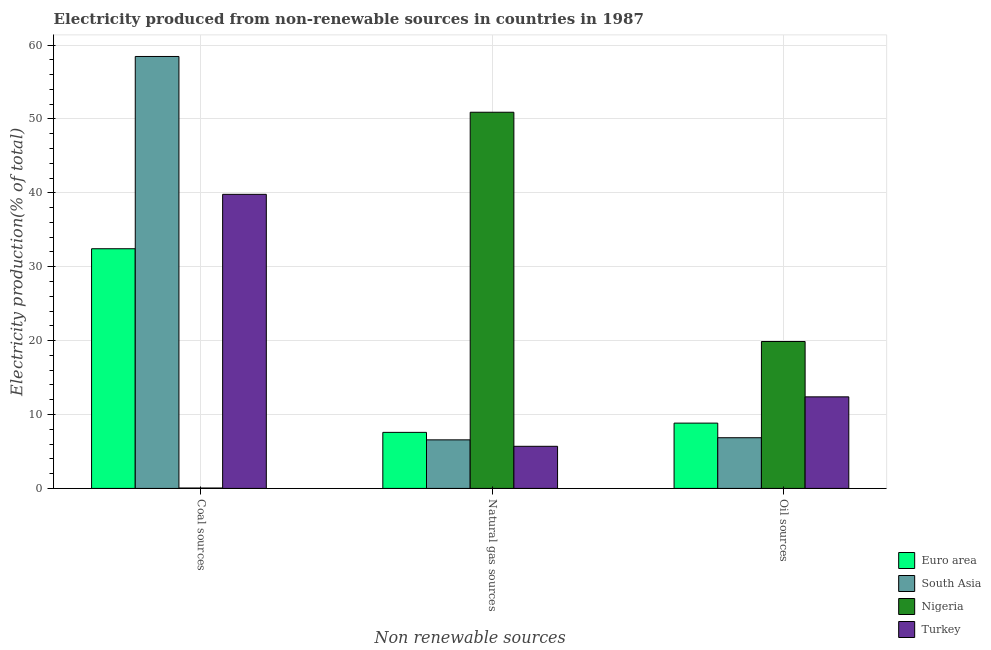How many groups of bars are there?
Provide a short and direct response. 3. Are the number of bars per tick equal to the number of legend labels?
Make the answer very short. Yes. Are the number of bars on each tick of the X-axis equal?
Provide a succinct answer. Yes. How many bars are there on the 3rd tick from the left?
Your answer should be compact. 4. What is the label of the 1st group of bars from the left?
Offer a very short reply. Coal sources. What is the percentage of electricity produced by natural gas in Nigeria?
Your answer should be very brief. 50.91. Across all countries, what is the maximum percentage of electricity produced by coal?
Provide a succinct answer. 58.46. Across all countries, what is the minimum percentage of electricity produced by coal?
Offer a terse response. 0.05. In which country was the percentage of electricity produced by oil sources maximum?
Your answer should be compact. Nigeria. What is the total percentage of electricity produced by coal in the graph?
Provide a succinct answer. 130.75. What is the difference between the percentage of electricity produced by natural gas in Nigeria and that in Turkey?
Ensure brevity in your answer.  45.21. What is the difference between the percentage of electricity produced by natural gas in Euro area and the percentage of electricity produced by oil sources in South Asia?
Offer a terse response. 0.73. What is the average percentage of electricity produced by natural gas per country?
Provide a succinct answer. 17.69. What is the difference between the percentage of electricity produced by natural gas and percentage of electricity produced by coal in Nigeria?
Offer a terse response. 50.86. In how many countries, is the percentage of electricity produced by coal greater than 24 %?
Ensure brevity in your answer.  3. What is the ratio of the percentage of electricity produced by natural gas in South Asia to that in Nigeria?
Make the answer very short. 0.13. Is the percentage of electricity produced by natural gas in Euro area less than that in South Asia?
Provide a succinct answer. No. What is the difference between the highest and the second highest percentage of electricity produced by coal?
Provide a short and direct response. 18.66. What is the difference between the highest and the lowest percentage of electricity produced by natural gas?
Make the answer very short. 45.21. Is the sum of the percentage of electricity produced by natural gas in Nigeria and South Asia greater than the maximum percentage of electricity produced by coal across all countries?
Make the answer very short. No. What does the 2nd bar from the right in Coal sources represents?
Provide a short and direct response. Nigeria. Is it the case that in every country, the sum of the percentage of electricity produced by coal and percentage of electricity produced by natural gas is greater than the percentage of electricity produced by oil sources?
Your answer should be very brief. Yes. How many bars are there?
Keep it short and to the point. 12. How many countries are there in the graph?
Offer a terse response. 4. What is the difference between two consecutive major ticks on the Y-axis?
Your response must be concise. 10. Where does the legend appear in the graph?
Give a very brief answer. Bottom right. How are the legend labels stacked?
Your response must be concise. Vertical. What is the title of the graph?
Make the answer very short. Electricity produced from non-renewable sources in countries in 1987. What is the label or title of the X-axis?
Offer a very short reply. Non renewable sources. What is the label or title of the Y-axis?
Provide a short and direct response. Electricity production(% of total). What is the Electricity production(% of total) in Euro area in Coal sources?
Your response must be concise. 32.44. What is the Electricity production(% of total) of South Asia in Coal sources?
Your answer should be very brief. 58.46. What is the Electricity production(% of total) in Nigeria in Coal sources?
Provide a succinct answer. 0.05. What is the Electricity production(% of total) of Turkey in Coal sources?
Offer a very short reply. 39.8. What is the Electricity production(% of total) of Euro area in Natural gas sources?
Your response must be concise. 7.58. What is the Electricity production(% of total) of South Asia in Natural gas sources?
Provide a succinct answer. 6.57. What is the Electricity production(% of total) of Nigeria in Natural gas sources?
Give a very brief answer. 50.91. What is the Electricity production(% of total) of Turkey in Natural gas sources?
Your answer should be compact. 5.7. What is the Electricity production(% of total) of Euro area in Oil sources?
Provide a succinct answer. 8.84. What is the Electricity production(% of total) of South Asia in Oil sources?
Your answer should be compact. 6.86. What is the Electricity production(% of total) of Nigeria in Oil sources?
Keep it short and to the point. 19.88. What is the Electricity production(% of total) in Turkey in Oil sources?
Provide a succinct answer. 12.39. Across all Non renewable sources, what is the maximum Electricity production(% of total) of Euro area?
Make the answer very short. 32.44. Across all Non renewable sources, what is the maximum Electricity production(% of total) in South Asia?
Keep it short and to the point. 58.46. Across all Non renewable sources, what is the maximum Electricity production(% of total) in Nigeria?
Your answer should be very brief. 50.91. Across all Non renewable sources, what is the maximum Electricity production(% of total) in Turkey?
Ensure brevity in your answer.  39.8. Across all Non renewable sources, what is the minimum Electricity production(% of total) of Euro area?
Keep it short and to the point. 7.58. Across all Non renewable sources, what is the minimum Electricity production(% of total) of South Asia?
Your answer should be very brief. 6.57. Across all Non renewable sources, what is the minimum Electricity production(% of total) in Nigeria?
Make the answer very short. 0.05. Across all Non renewable sources, what is the minimum Electricity production(% of total) of Turkey?
Give a very brief answer. 5.7. What is the total Electricity production(% of total) in Euro area in the graph?
Make the answer very short. 48.86. What is the total Electricity production(% of total) in South Asia in the graph?
Your answer should be compact. 71.89. What is the total Electricity production(% of total) of Nigeria in the graph?
Give a very brief answer. 70.85. What is the total Electricity production(% of total) of Turkey in the graph?
Provide a short and direct response. 57.89. What is the difference between the Electricity production(% of total) in Euro area in Coal sources and that in Natural gas sources?
Your response must be concise. 24.85. What is the difference between the Electricity production(% of total) in South Asia in Coal sources and that in Natural gas sources?
Give a very brief answer. 51.89. What is the difference between the Electricity production(% of total) of Nigeria in Coal sources and that in Natural gas sources?
Offer a very short reply. -50.86. What is the difference between the Electricity production(% of total) of Turkey in Coal sources and that in Natural gas sources?
Make the answer very short. 34.1. What is the difference between the Electricity production(% of total) in Euro area in Coal sources and that in Oil sources?
Give a very brief answer. 23.6. What is the difference between the Electricity production(% of total) in South Asia in Coal sources and that in Oil sources?
Give a very brief answer. 51.6. What is the difference between the Electricity production(% of total) of Nigeria in Coal sources and that in Oil sources?
Offer a very short reply. -19.83. What is the difference between the Electricity production(% of total) of Turkey in Coal sources and that in Oil sources?
Make the answer very short. 27.41. What is the difference between the Electricity production(% of total) of Euro area in Natural gas sources and that in Oil sources?
Provide a succinct answer. -1.25. What is the difference between the Electricity production(% of total) in South Asia in Natural gas sources and that in Oil sources?
Offer a terse response. -0.29. What is the difference between the Electricity production(% of total) in Nigeria in Natural gas sources and that in Oil sources?
Provide a short and direct response. 31.03. What is the difference between the Electricity production(% of total) in Turkey in Natural gas sources and that in Oil sources?
Give a very brief answer. -6.69. What is the difference between the Electricity production(% of total) of Euro area in Coal sources and the Electricity production(% of total) of South Asia in Natural gas sources?
Ensure brevity in your answer.  25.86. What is the difference between the Electricity production(% of total) in Euro area in Coal sources and the Electricity production(% of total) in Nigeria in Natural gas sources?
Make the answer very short. -18.47. What is the difference between the Electricity production(% of total) of Euro area in Coal sources and the Electricity production(% of total) of Turkey in Natural gas sources?
Provide a succinct answer. 26.74. What is the difference between the Electricity production(% of total) in South Asia in Coal sources and the Electricity production(% of total) in Nigeria in Natural gas sources?
Give a very brief answer. 7.55. What is the difference between the Electricity production(% of total) of South Asia in Coal sources and the Electricity production(% of total) of Turkey in Natural gas sources?
Provide a short and direct response. 52.76. What is the difference between the Electricity production(% of total) of Nigeria in Coal sources and the Electricity production(% of total) of Turkey in Natural gas sources?
Your response must be concise. -5.65. What is the difference between the Electricity production(% of total) of Euro area in Coal sources and the Electricity production(% of total) of South Asia in Oil sources?
Offer a terse response. 25.58. What is the difference between the Electricity production(% of total) in Euro area in Coal sources and the Electricity production(% of total) in Nigeria in Oil sources?
Your answer should be compact. 12.55. What is the difference between the Electricity production(% of total) in Euro area in Coal sources and the Electricity production(% of total) in Turkey in Oil sources?
Offer a very short reply. 20.04. What is the difference between the Electricity production(% of total) in South Asia in Coal sources and the Electricity production(% of total) in Nigeria in Oil sources?
Provide a short and direct response. 38.57. What is the difference between the Electricity production(% of total) of South Asia in Coal sources and the Electricity production(% of total) of Turkey in Oil sources?
Provide a succinct answer. 46.07. What is the difference between the Electricity production(% of total) in Nigeria in Coal sources and the Electricity production(% of total) in Turkey in Oil sources?
Provide a short and direct response. -12.34. What is the difference between the Electricity production(% of total) of Euro area in Natural gas sources and the Electricity production(% of total) of South Asia in Oil sources?
Provide a short and direct response. 0.73. What is the difference between the Electricity production(% of total) of Euro area in Natural gas sources and the Electricity production(% of total) of Nigeria in Oil sources?
Offer a very short reply. -12.3. What is the difference between the Electricity production(% of total) in Euro area in Natural gas sources and the Electricity production(% of total) in Turkey in Oil sources?
Offer a terse response. -4.81. What is the difference between the Electricity production(% of total) of South Asia in Natural gas sources and the Electricity production(% of total) of Nigeria in Oil sources?
Offer a terse response. -13.31. What is the difference between the Electricity production(% of total) of South Asia in Natural gas sources and the Electricity production(% of total) of Turkey in Oil sources?
Your response must be concise. -5.82. What is the difference between the Electricity production(% of total) in Nigeria in Natural gas sources and the Electricity production(% of total) in Turkey in Oil sources?
Keep it short and to the point. 38.52. What is the average Electricity production(% of total) of Euro area per Non renewable sources?
Keep it short and to the point. 16.29. What is the average Electricity production(% of total) in South Asia per Non renewable sources?
Ensure brevity in your answer.  23.96. What is the average Electricity production(% of total) in Nigeria per Non renewable sources?
Give a very brief answer. 23.62. What is the average Electricity production(% of total) in Turkey per Non renewable sources?
Your response must be concise. 19.3. What is the difference between the Electricity production(% of total) in Euro area and Electricity production(% of total) in South Asia in Coal sources?
Ensure brevity in your answer.  -26.02. What is the difference between the Electricity production(% of total) in Euro area and Electricity production(% of total) in Nigeria in Coal sources?
Keep it short and to the point. 32.38. What is the difference between the Electricity production(% of total) of Euro area and Electricity production(% of total) of Turkey in Coal sources?
Your response must be concise. -7.36. What is the difference between the Electricity production(% of total) in South Asia and Electricity production(% of total) in Nigeria in Coal sources?
Keep it short and to the point. 58.41. What is the difference between the Electricity production(% of total) in South Asia and Electricity production(% of total) in Turkey in Coal sources?
Offer a very short reply. 18.66. What is the difference between the Electricity production(% of total) of Nigeria and Electricity production(% of total) of Turkey in Coal sources?
Make the answer very short. -39.75. What is the difference between the Electricity production(% of total) in Euro area and Electricity production(% of total) in South Asia in Natural gas sources?
Make the answer very short. 1.01. What is the difference between the Electricity production(% of total) in Euro area and Electricity production(% of total) in Nigeria in Natural gas sources?
Your response must be concise. -43.33. What is the difference between the Electricity production(% of total) in Euro area and Electricity production(% of total) in Turkey in Natural gas sources?
Offer a very short reply. 1.89. What is the difference between the Electricity production(% of total) of South Asia and Electricity production(% of total) of Nigeria in Natural gas sources?
Keep it short and to the point. -44.34. What is the difference between the Electricity production(% of total) in South Asia and Electricity production(% of total) in Turkey in Natural gas sources?
Offer a terse response. 0.87. What is the difference between the Electricity production(% of total) of Nigeria and Electricity production(% of total) of Turkey in Natural gas sources?
Make the answer very short. 45.21. What is the difference between the Electricity production(% of total) of Euro area and Electricity production(% of total) of South Asia in Oil sources?
Provide a short and direct response. 1.98. What is the difference between the Electricity production(% of total) in Euro area and Electricity production(% of total) in Nigeria in Oil sources?
Provide a succinct answer. -11.05. What is the difference between the Electricity production(% of total) in Euro area and Electricity production(% of total) in Turkey in Oil sources?
Provide a short and direct response. -3.55. What is the difference between the Electricity production(% of total) in South Asia and Electricity production(% of total) in Nigeria in Oil sources?
Your response must be concise. -13.02. What is the difference between the Electricity production(% of total) of South Asia and Electricity production(% of total) of Turkey in Oil sources?
Ensure brevity in your answer.  -5.53. What is the difference between the Electricity production(% of total) in Nigeria and Electricity production(% of total) in Turkey in Oil sources?
Your answer should be very brief. 7.49. What is the ratio of the Electricity production(% of total) of Euro area in Coal sources to that in Natural gas sources?
Offer a very short reply. 4.28. What is the ratio of the Electricity production(% of total) in South Asia in Coal sources to that in Natural gas sources?
Make the answer very short. 8.89. What is the ratio of the Electricity production(% of total) in Nigeria in Coal sources to that in Natural gas sources?
Your response must be concise. 0. What is the ratio of the Electricity production(% of total) of Turkey in Coal sources to that in Natural gas sources?
Your answer should be very brief. 6.98. What is the ratio of the Electricity production(% of total) in Euro area in Coal sources to that in Oil sources?
Your answer should be very brief. 3.67. What is the ratio of the Electricity production(% of total) in South Asia in Coal sources to that in Oil sources?
Make the answer very short. 8.52. What is the ratio of the Electricity production(% of total) in Nigeria in Coal sources to that in Oil sources?
Your response must be concise. 0. What is the ratio of the Electricity production(% of total) of Turkey in Coal sources to that in Oil sources?
Offer a terse response. 3.21. What is the ratio of the Electricity production(% of total) of Euro area in Natural gas sources to that in Oil sources?
Your answer should be compact. 0.86. What is the ratio of the Electricity production(% of total) in South Asia in Natural gas sources to that in Oil sources?
Your response must be concise. 0.96. What is the ratio of the Electricity production(% of total) in Nigeria in Natural gas sources to that in Oil sources?
Give a very brief answer. 2.56. What is the ratio of the Electricity production(% of total) of Turkey in Natural gas sources to that in Oil sources?
Make the answer very short. 0.46. What is the difference between the highest and the second highest Electricity production(% of total) of Euro area?
Make the answer very short. 23.6. What is the difference between the highest and the second highest Electricity production(% of total) in South Asia?
Provide a short and direct response. 51.6. What is the difference between the highest and the second highest Electricity production(% of total) of Nigeria?
Keep it short and to the point. 31.03. What is the difference between the highest and the second highest Electricity production(% of total) of Turkey?
Offer a very short reply. 27.41. What is the difference between the highest and the lowest Electricity production(% of total) in Euro area?
Make the answer very short. 24.85. What is the difference between the highest and the lowest Electricity production(% of total) in South Asia?
Offer a terse response. 51.89. What is the difference between the highest and the lowest Electricity production(% of total) in Nigeria?
Your response must be concise. 50.86. What is the difference between the highest and the lowest Electricity production(% of total) of Turkey?
Your answer should be compact. 34.1. 